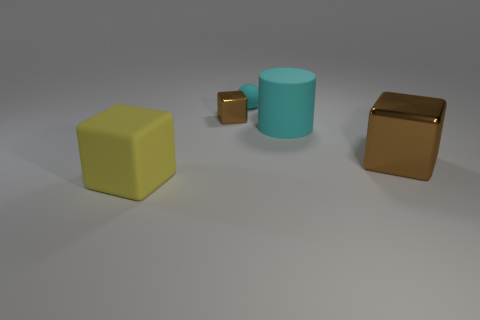Add 1 big brown metal objects. How many objects exist? 6 Subtract all cubes. How many objects are left? 2 Subtract 1 cyan balls. How many objects are left? 4 Subtract all tiny brown shiny objects. Subtract all metallic cubes. How many objects are left? 2 Add 3 brown metal cubes. How many brown metal cubes are left? 5 Add 2 small cyan spheres. How many small cyan spheres exist? 3 